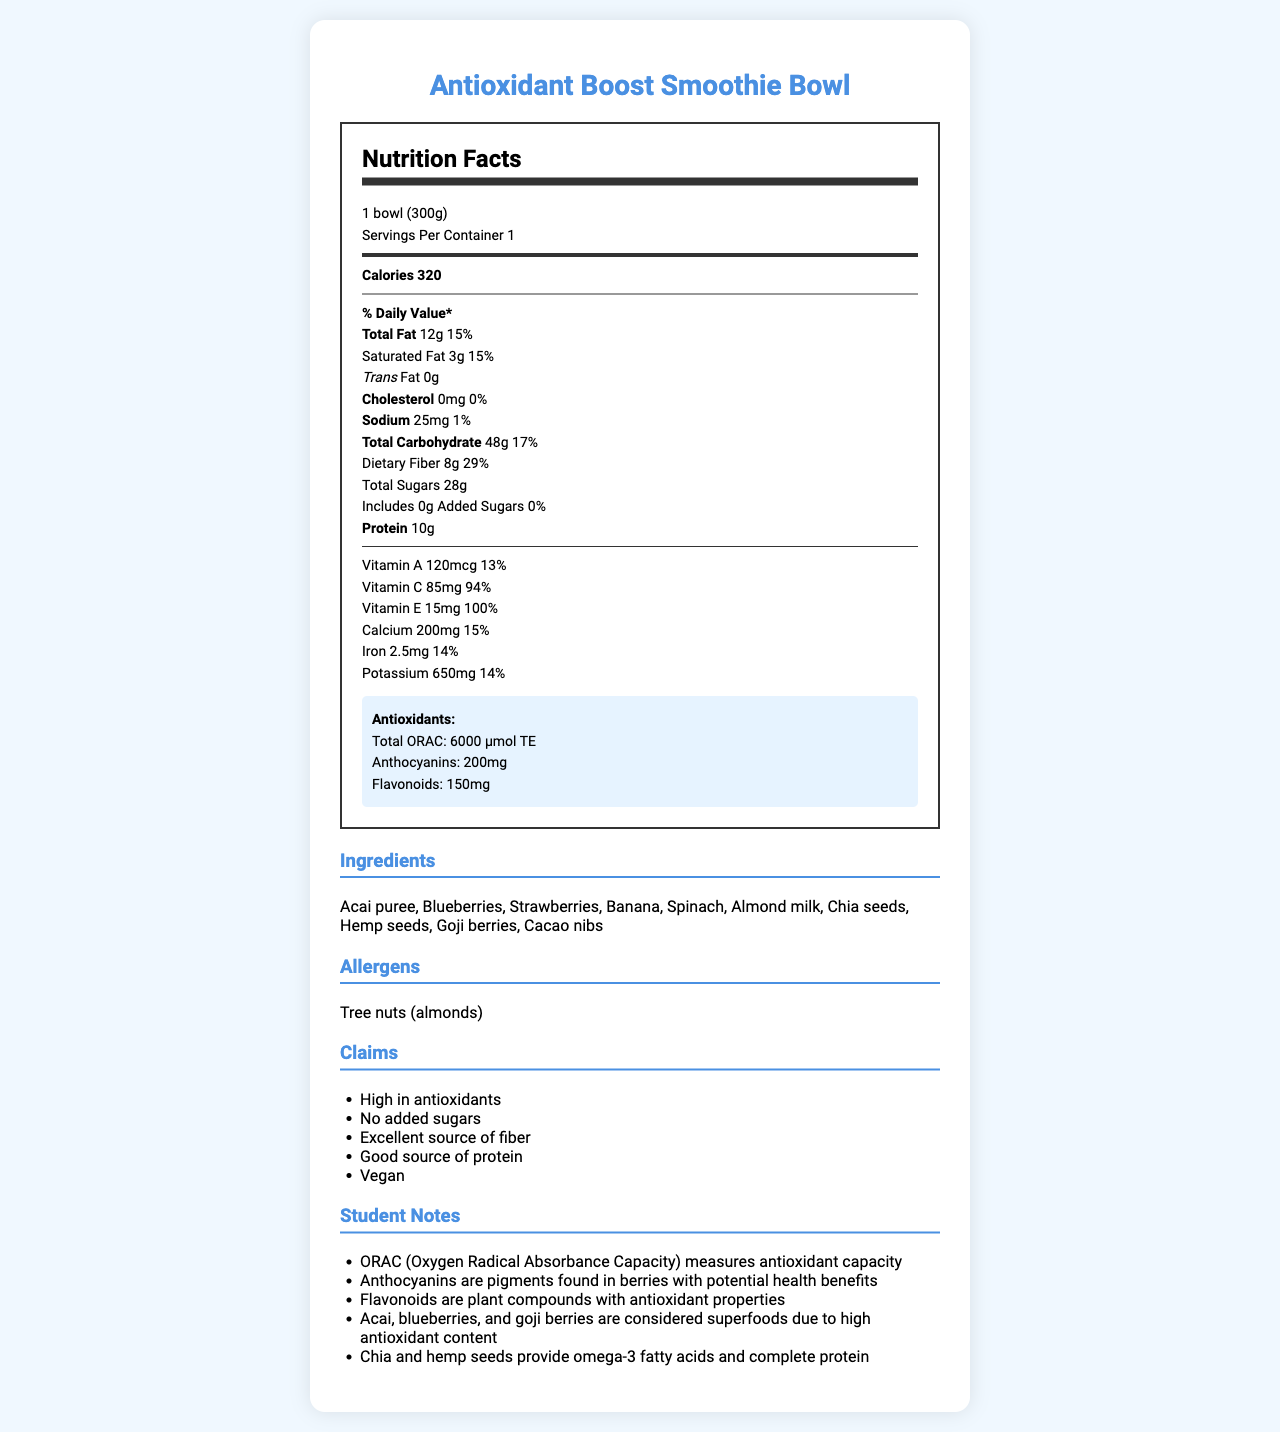how many grams of dietary fiber does the Antioxidant Boost Smoothie Bowl contain? According to the nutrition facts, the dietary fiber content is listed as 8g.
Answer: 8g what is the serving size for the Antioxidant Boost Smoothie Bowl? The serving size is listed as 1 bowl (300g) in the nutrition facts.
Answer: 1 bowl (300g) what percentage of the daily value for vitamin C does one smoothie bowl provide? The document states that the smoothie bowl provides 94% of the daily value for vitamin C.
Answer: 94% how much protein is in the Antioxidant Boost Smoothie Bowl? The nutrition facts label lists the protein content as 10g.
Answer: 10g what is the unique antioxidant compound found in high amounts in berries, as listed in the student notes? According to the student notes, anthocyanins are pigments found in berries with potential health benefits.
Answer: Anthocyanins which of these ingredients is not in the Antioxidant Boost Smoothie Bowl? A. Acai puree B. Quinoa C. Goji berries D. Banana The ingredients list includes acai puree, goji berries, and banana, but not quinoa.
Answer: B what type of dietary claim is NOT made on the label? A. High in antioxidants B. Gluten-free C. Vegan D. Excellent source of fiber The claims listed on the document include high in antioxidants, no added sugars, excellent source of fiber, good source of protein, and vegan. Gluten-free is not mentioned.
Answer: B does the smoothie bowl contain any added sugars? The document specifies that the Antioxidant Boost Smoothie Bowl contains 0g of added sugars.
Answer: No does the document state that anthocyanins are the only type of antioxidant in the smoothie bowl? The document lists anthocyanins as one of the antioxidants but also mentions flavonoids and provides the total ORAC value.
Answer: No can you summarize the main idea of the document? The document provides detailed nutritional information, ingredients list, allergen warnings, health claims, and student notes highlighting the antioxidant content of the "Antioxidant Boost Smoothie Bowl."
Answer: It's a nutrition facts label for the "Antioxidant Boost Smoothie Bowl," showing it is high in antioxidants, has no added sugars, and provides a good source of fiber and protein. what is the retail price of the Antioxidant Boost Smoothie Bowl? The document does not provide any information about the retail price of the smoothie bowl.
Answer: Not enough information 